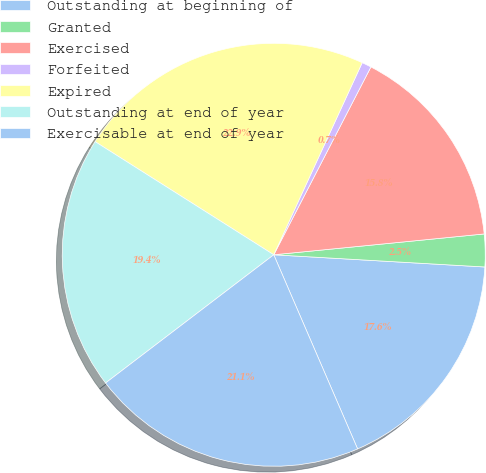<chart> <loc_0><loc_0><loc_500><loc_500><pie_chart><fcel>Outstanding at beginning of<fcel>Granted<fcel>Exercised<fcel>Forfeited<fcel>Expired<fcel>Outstanding at end of year<fcel>Exercisable at end of year<nl><fcel>17.59%<fcel>2.49%<fcel>15.83%<fcel>0.73%<fcel>22.88%<fcel>19.35%<fcel>21.12%<nl></chart> 